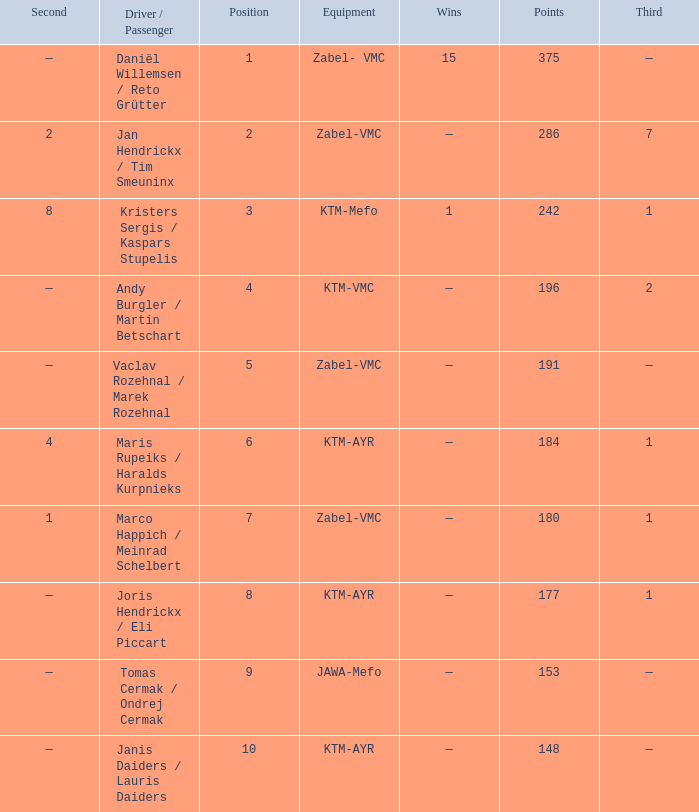Who was the driver/passengar when the position was smaller than 8, the third was 1, and there was 1 win? Kristers Sergis / Kaspars Stupelis. 